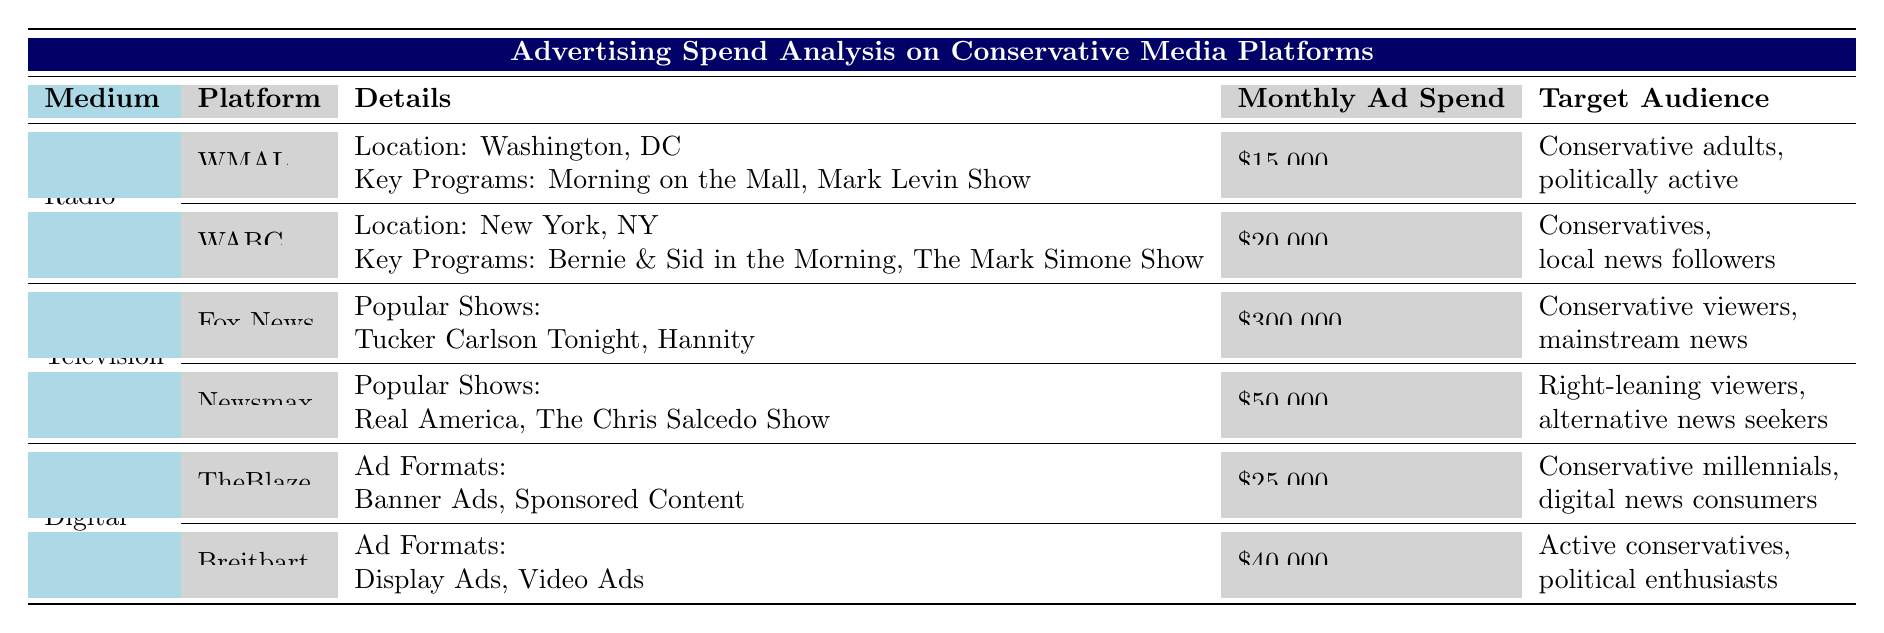What is the monthly ad spend for WMAL? The table lists WMAL under the Radio section and states that its Monthly Ad Spend is $15,000.
Answer: $15,000 Which conservative media platform has the highest monthly ad spend? By comparing the monthly ad spends, Fox News has the highest at $300,000, more than any other platform listed.
Answer: Fox News How much more does WABC spend on advertising compared to WMAL? WABC spends $20,000 and WMAL spends $15,000. The difference is $20,000 - $15,000 = $5,000.
Answer: $5,000 Is the target audience for Newsmax focused on conservative viewers? The target audience for Newsmax is described as 'Right-leaning viewers, alternative news seekers', which indicates a focus on a conservative demographic.
Answer: Yes What is the total monthly ad spend for all radio stations listed? The sum of the monthly ad spend for WMAL ($15,000) and WABC ($20,000) is $15,000 + $20,000 = $35,000.
Answer: $35,000 Which platform has a target audience of conservative millennials? TheBlaze is the platform that targets conservative millennials, as indicated in the Target Audience column.
Answer: TheBlaze If you combine the monthly ad spends for Digital platforms, what is the total? The total for Digital platforms is the sum of TheBlaze ($25,000) and Breitbart ($40,000), amounting to $25,000 + $40,000 = $65,000.
Answer: $65,000 Are the key programs for WMAL and WABC the same? WMAL's key programs are "Morning on the Mall" and "Mark Levin Show", while WABC's are "Bernie & Sid in the Morning" and "The Mark Simone Show", indicating they are different.
Answer: No Which television platform has the lowest monthly ad spend? By comparing the monthly ad spends of Fox News ($300,000) and Newsmax ($50,000), Newsmax has the lowest ad spend of the two.
Answer: Newsmax 